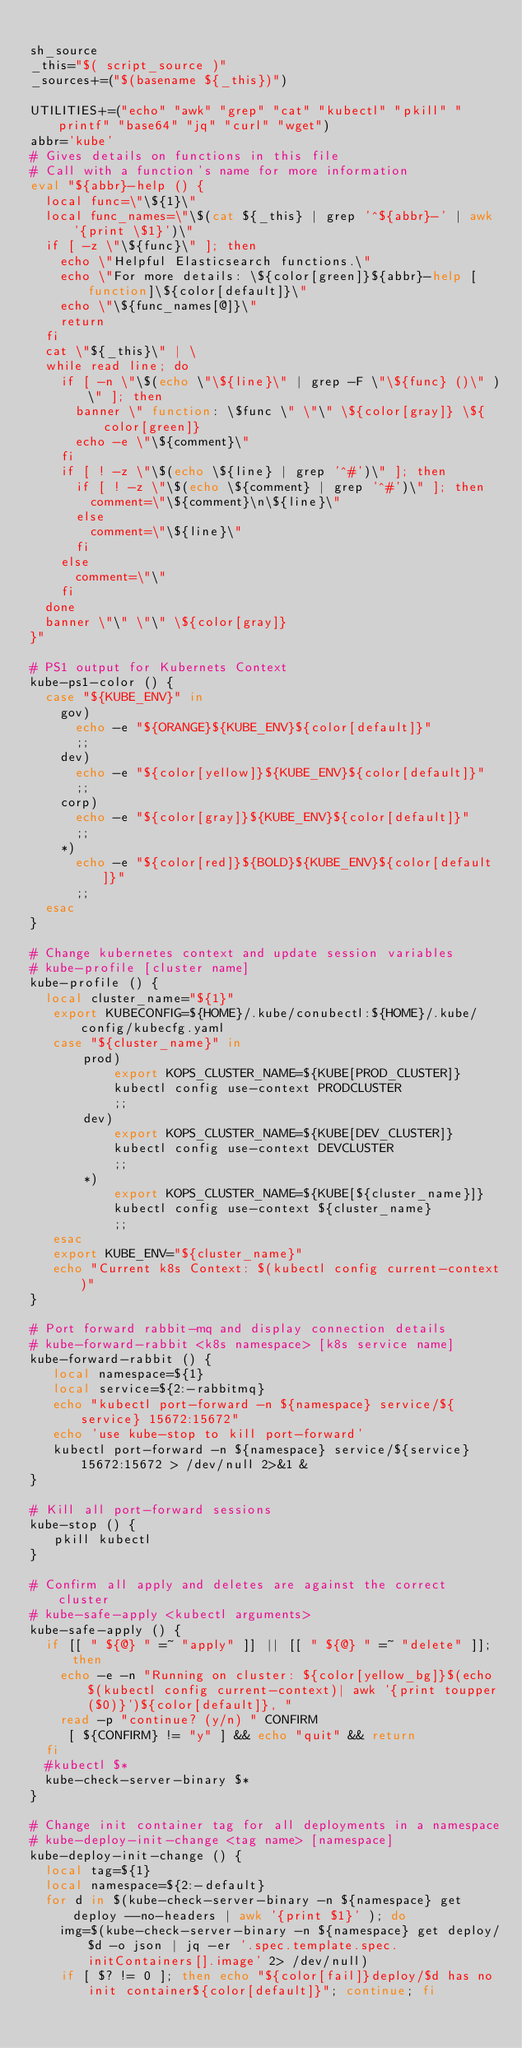Convert code to text. <code><loc_0><loc_0><loc_500><loc_500><_Bash_>
sh_source
_this="$( script_source )"
_sources+=("$(basename ${_this})")

UTILITIES+=("echo" "awk" "grep" "cat" "kubectl" "pkill" "printf" "base64" "jq" "curl" "wget")
abbr='kube'
# Gives details on functions in this file
# Call with a function's name for more information
eval "${abbr}-help () {
  local func=\"\${1}\"
  local func_names=\"\$(cat ${_this} | grep '^${abbr}-' | awk '{print \$1}')\"
  if [ -z \"\${func}\" ]; then
    echo \"Helpful Elasticsearch functions.\"
    echo \"For more details: \${color[green]}${abbr}-help [function]\${color[default]}\"
    echo \"\${func_names[@]}\"
    return
  fi
  cat \"${_this}\" | \
  while read line; do
		if [ -n \"\$(echo \"\${line}\" | grep -F \"\${func} ()\" )\" ]; then
      banner \" function: \$func \" \"\" \${color[gray]} \${color[green]}
      echo -e \"\${comment}\"
    fi
    if [ ! -z \"\$(echo \${line} | grep '^#')\" ]; then 
      if [ ! -z \"\$(echo \${comment} | grep '^#')\" ]; then
        comment=\"\${comment}\n\${line}\"
      else
        comment=\"\${line}\"
      fi
    else
      comment=\"\"
    fi
  done  
  banner \"\" \"\" \${color[gray]}
}"

# PS1 output for Kubernets Context
kube-ps1-color () {
  case "${KUBE_ENV}" in
    gov)
      echo -e "${ORANGE}${KUBE_ENV}${color[default]}"
      ;;
    dev)
      echo -e "${color[yellow]}${KUBE_ENV}${color[default]}"
      ;;
    corp)
      echo -e "${color[gray]}${KUBE_ENV}${color[default]}"
      ;;
    *)
      echo -e "${color[red]}${BOLD}${KUBE_ENV}${color[default]}"
      ;;
  esac
}

# Change kubernetes context and update session variables
# kube-profile [cluster name]
kube-profile () {
  local cluster_name="${1}"
   export KUBECONFIG=${HOME}/.kube/conubectl:${HOME}/.kube/config/kubecfg.yaml
   case "${cluster_name}" in
       prod)
           export KOPS_CLUSTER_NAME=${KUBE[PROD_CLUSTER]}
           kubectl config use-context PRODCLUSTER
           ;;
       dev)
           export KOPS_CLUSTER_NAME=${KUBE[DEV_CLUSTER]}
           kubectl config use-context DEVCLUSTER
           ;;
       *)
           export KOPS_CLUSTER_NAME=${KUBE[${cluster_name}]}
           kubectl config use-context ${cluster_name}
           ;;
   esac
   export KUBE_ENV="${cluster_name}"
   echo "Current k8s Context: $(kubectl config current-context)" 
}

# Port forward rabbit-mq and display connection details
# kube-forward-rabbit <k8s namespace> [k8s service name]
kube-forward-rabbit () {
   local namespace=${1}
   local service=${2:-rabbitmq}
   echo "kubectl port-forward -n ${namespace} service/${service} 15672:15672"
   echo 'use kube-stop to kill port-forward'
   kubectl port-forward -n ${namespace} service/${service} 15672:15672 > /dev/null 2>&1 &
}

# Kill all port-forward sessions
kube-stop () {
   pkill kubectl
}

# Confirm all apply and deletes are against the correct cluster
# kube-safe-apply <kubectl arguments>
kube-safe-apply () {
  if [[ " ${@} " =~ "apply" ]] || [[ " ${@} " =~ "delete" ]]; then 
    echo -e -n "Running on cluster: ${color[yellow_bg]}$(echo $(kubectl config current-context)| awk '{print toupper($0)}')${color[default]}, "
    read -p "continue? (y/n) " CONFIRM
     [ ${CONFIRM} != "y" ] && echo "quit" && return
  fi
  #kubectl $*
  kube-check-server-binary $*
}

# Change init container tag for all deployments in a namespace
# kube-deploy-init-change <tag name> [namespace]
kube-deploy-init-change () {
  local tag=${1}
  local namespace=${2:-default}
  for d in $(kube-check-server-binary -n ${namespace} get deploy --no-headers | awk '{print $1}' ); do 
    img=$(kube-check-server-binary -n ${namespace} get deploy/$d -o json | jq -er '.spec.template.spec.initContainers[].image' 2> /dev/null)
    if [ $? != 0 ]; then echo "${color[fail]}deploy/$d has no init container${color[default]}"; continue; fi</code> 